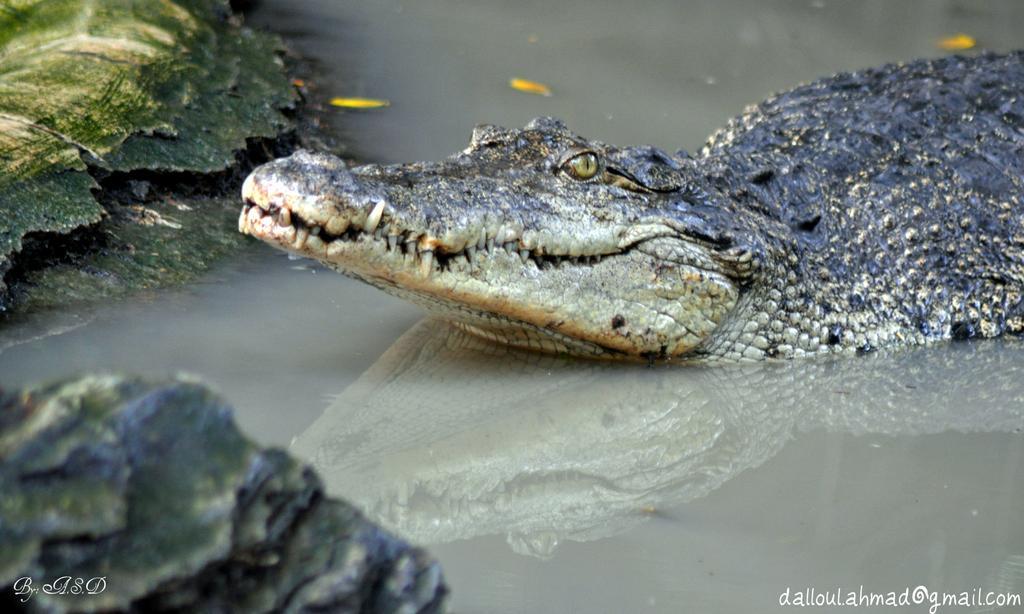Could you give a brief overview of what you see in this image? In the center of the image a crocodile is present on the water. On the left side of the image rocks are there. 